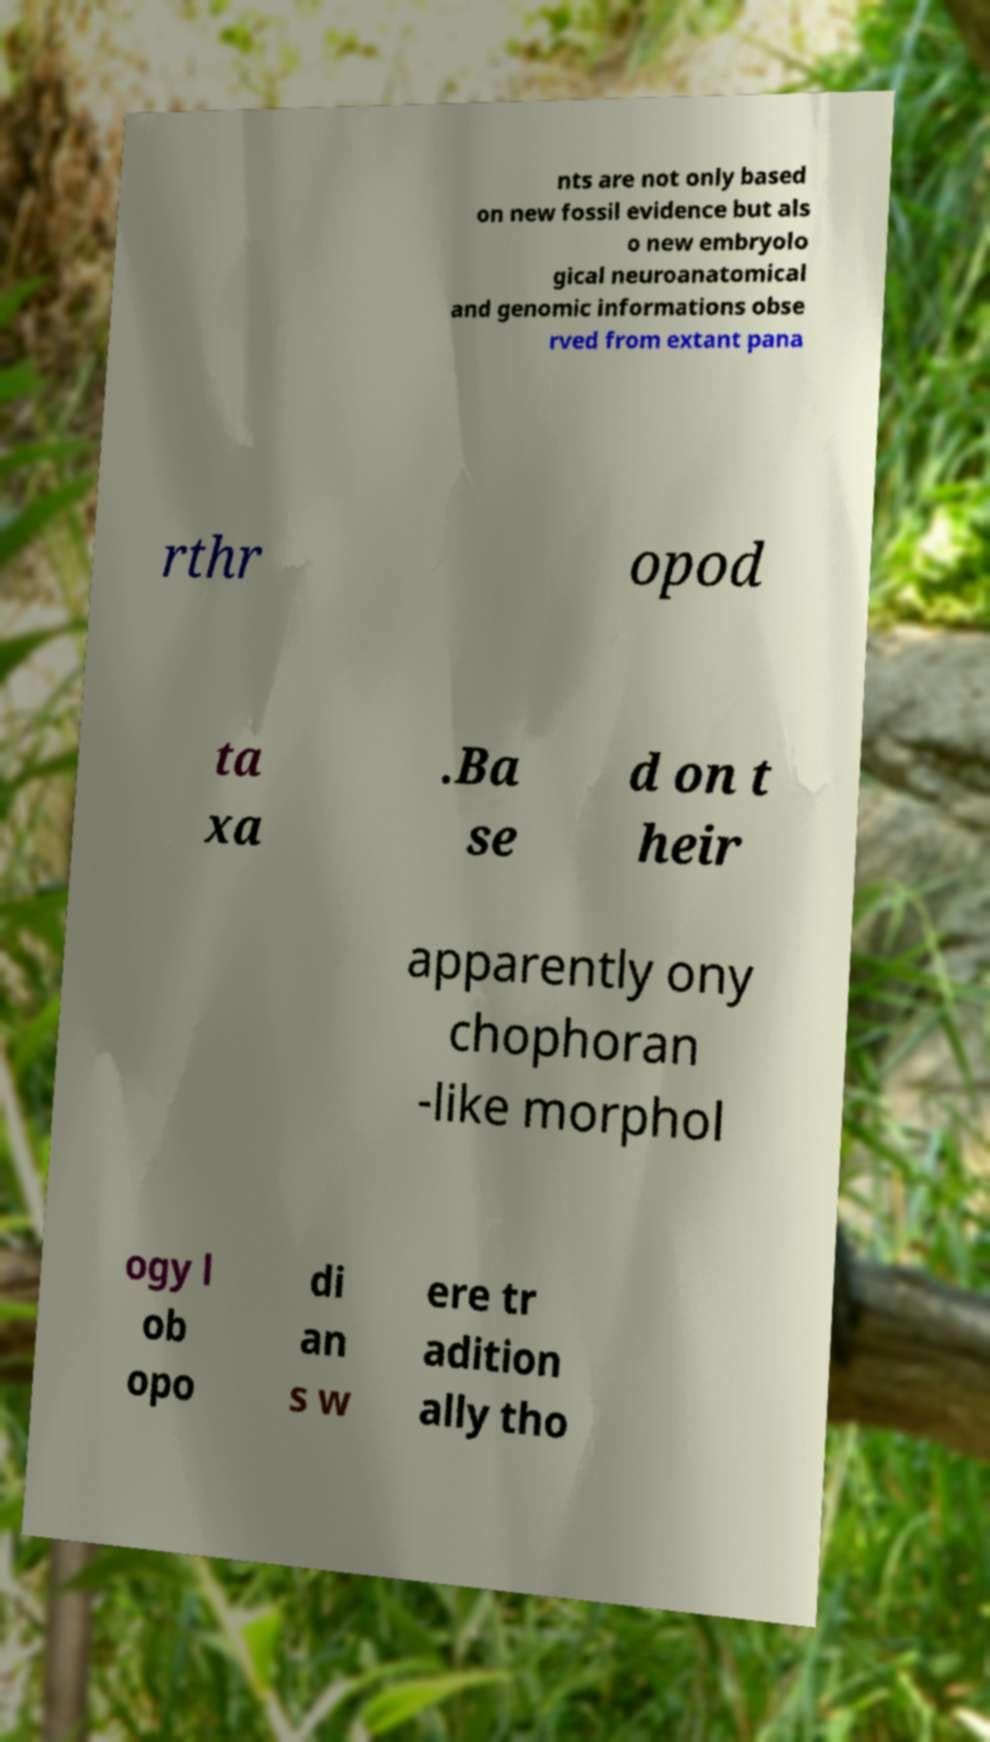Please read and relay the text visible in this image. What does it say? nts are not only based on new fossil evidence but als o new embryolo gical neuroanatomical and genomic informations obse rved from extant pana rthr opod ta xa .Ba se d on t heir apparently ony chophoran -like morphol ogy l ob opo di an s w ere tr adition ally tho 